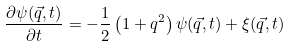Convert formula to latex. <formula><loc_0><loc_0><loc_500><loc_500>\frac { \partial \psi ( \vec { q } , t ) } { \partial t } = - \frac { 1 } { 2 } \left ( 1 + q ^ { 2 } \right ) \psi ( \vec { q } , t ) + \xi ( \vec { q } , t )</formula> 